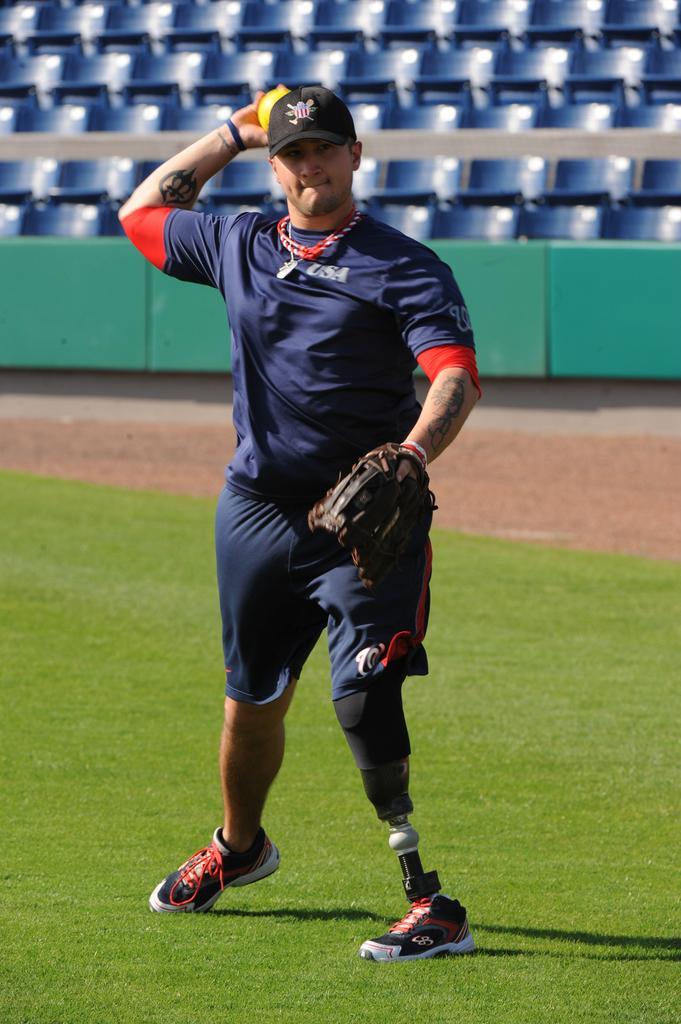Please provide a concise description of this image. In this image we can see a man wearing a glove holding a ball standing on the ground. On the backside we can see some grass, chairs and the fence. 